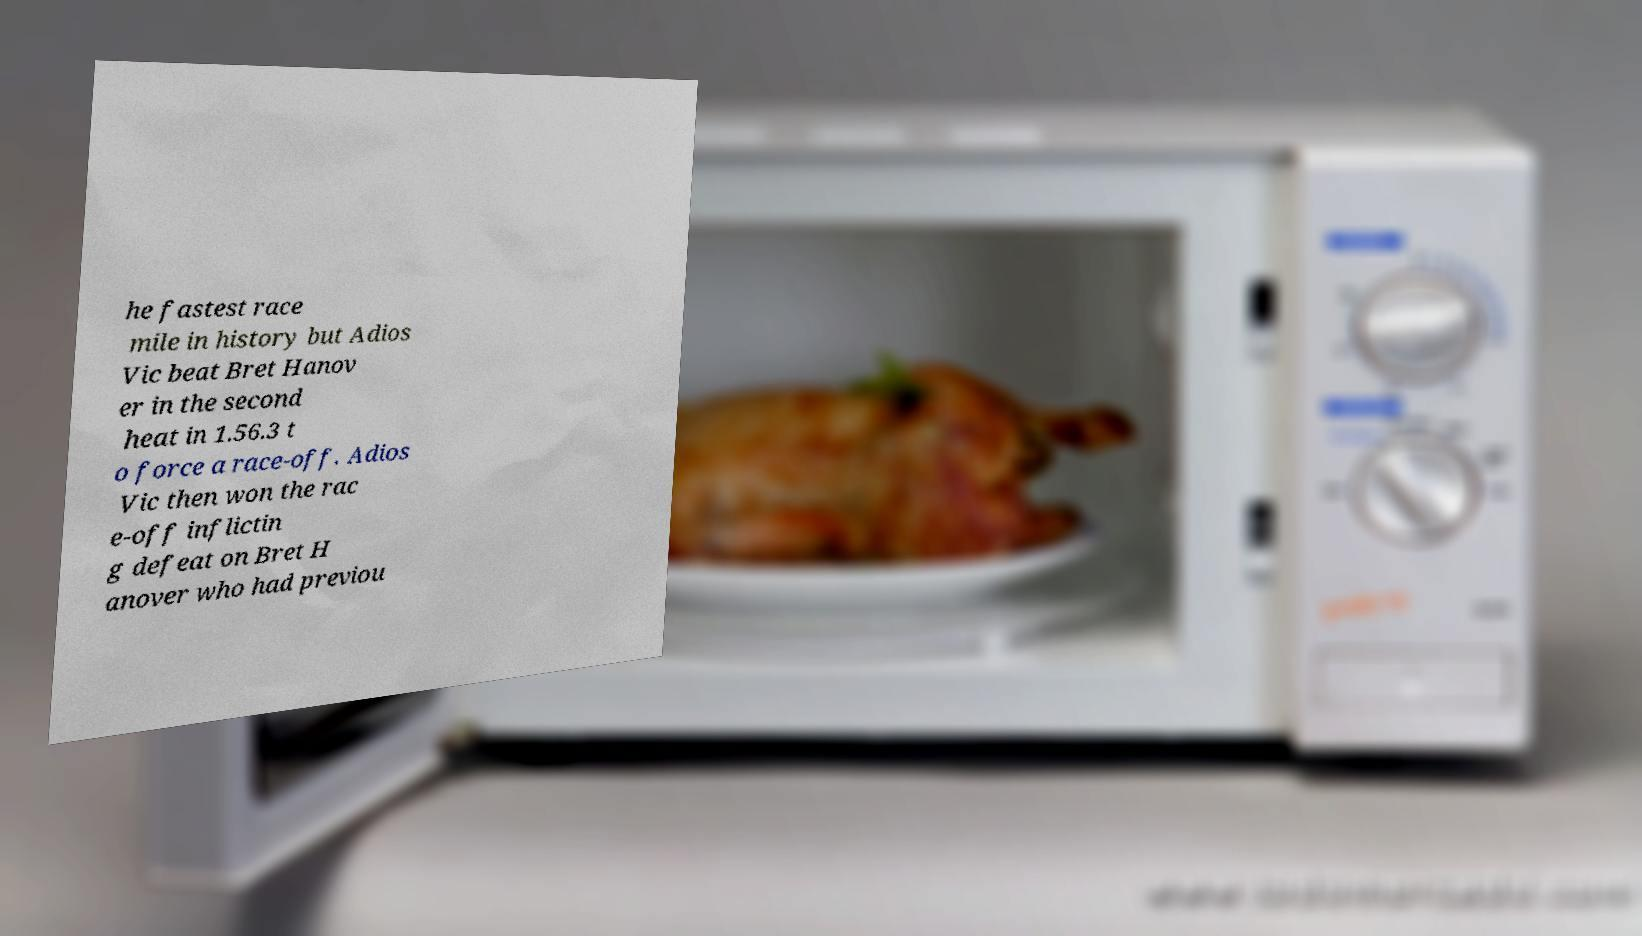Please read and relay the text visible in this image. What does it say? he fastest race mile in history but Adios Vic beat Bret Hanov er in the second heat in 1.56.3 t o force a race-off. Adios Vic then won the rac e-off inflictin g defeat on Bret H anover who had previou 